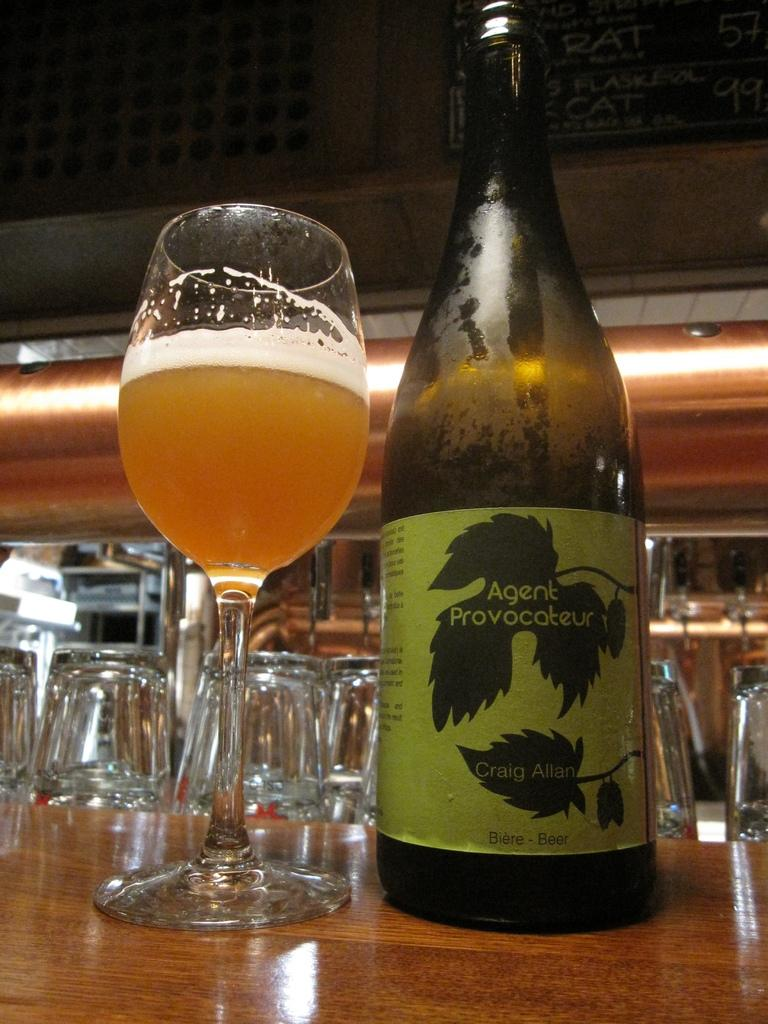<image>
Share a concise interpretation of the image provided. a glass and bottle of Agent Provocateur Beer on a tble 